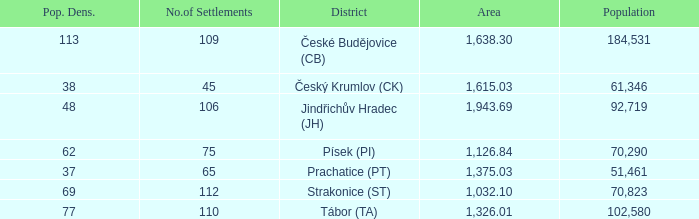How big is the area that has a population density of 113 and a population larger than 184,531? 0.0. 